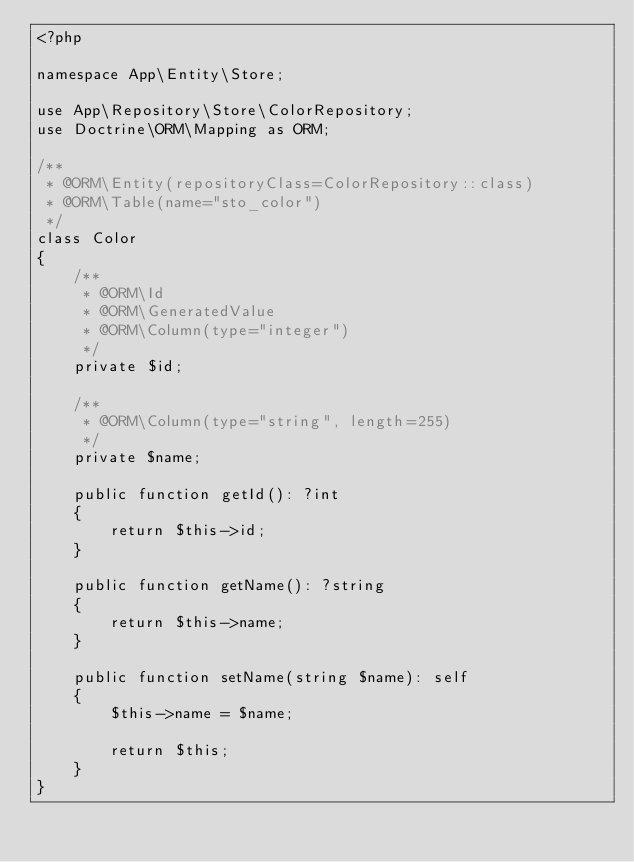Convert code to text. <code><loc_0><loc_0><loc_500><loc_500><_PHP_><?php

namespace App\Entity\Store;

use App\Repository\Store\ColorRepository;
use Doctrine\ORM\Mapping as ORM;

/**
 * @ORM\Entity(repositoryClass=ColorRepository::class)
 * @ORM\Table(name="sto_color")
 */
class Color
{
    /**
     * @ORM\Id
     * @ORM\GeneratedValue
     * @ORM\Column(type="integer")
     */
    private $id;

    /**
     * @ORM\Column(type="string", length=255)
     */
    private $name;

    public function getId(): ?int
    {
        return $this->id;
    }

    public function getName(): ?string
    {
        return $this->name;
    }

    public function setName(string $name): self
    {
        $this->name = $name;

        return $this;
    }
}
</code> 